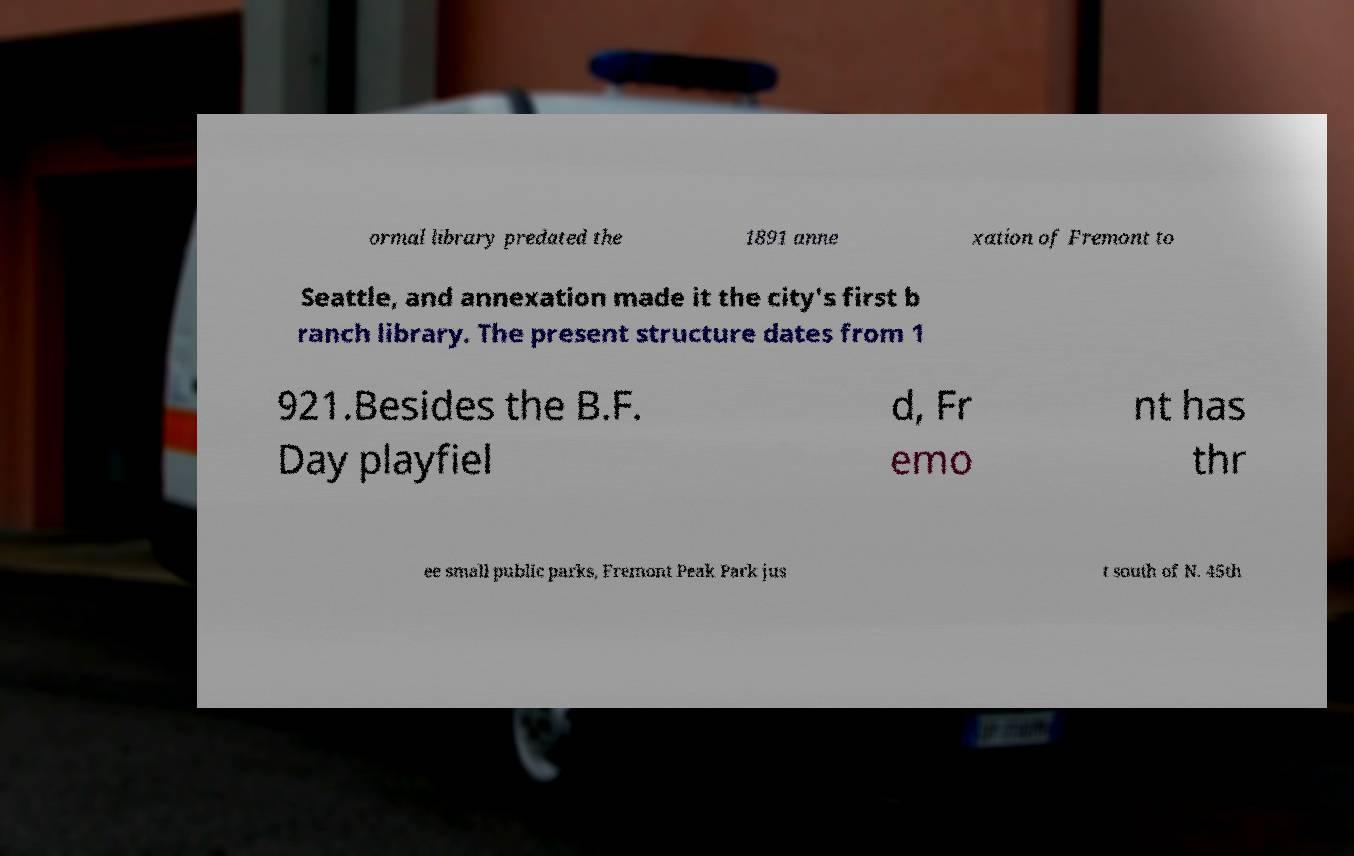I need the written content from this picture converted into text. Can you do that? ormal library predated the 1891 anne xation of Fremont to Seattle, and annexation made it the city's first b ranch library. The present structure dates from 1 921.Besides the B.F. Day playfiel d, Fr emo nt has thr ee small public parks, Fremont Peak Park jus t south of N. 45th 